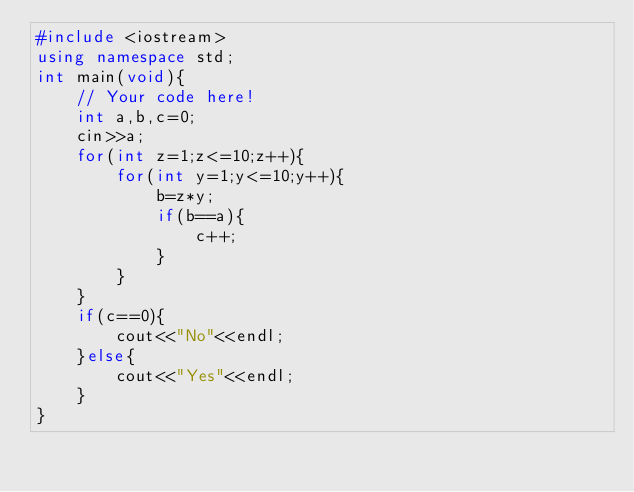<code> <loc_0><loc_0><loc_500><loc_500><_C++_>#include <iostream>
using namespace std;
int main(void){
    // Your code here!
    int a,b,c=0;
    cin>>a;
    for(int z=1;z<=10;z++){
        for(int y=1;y<=10;y++){
            b=z*y;
            if(b==a){
                c++;
            }
        }
    }
    if(c==0){
        cout<<"No"<<endl;
    }else{
        cout<<"Yes"<<endl;
    }
}</code> 